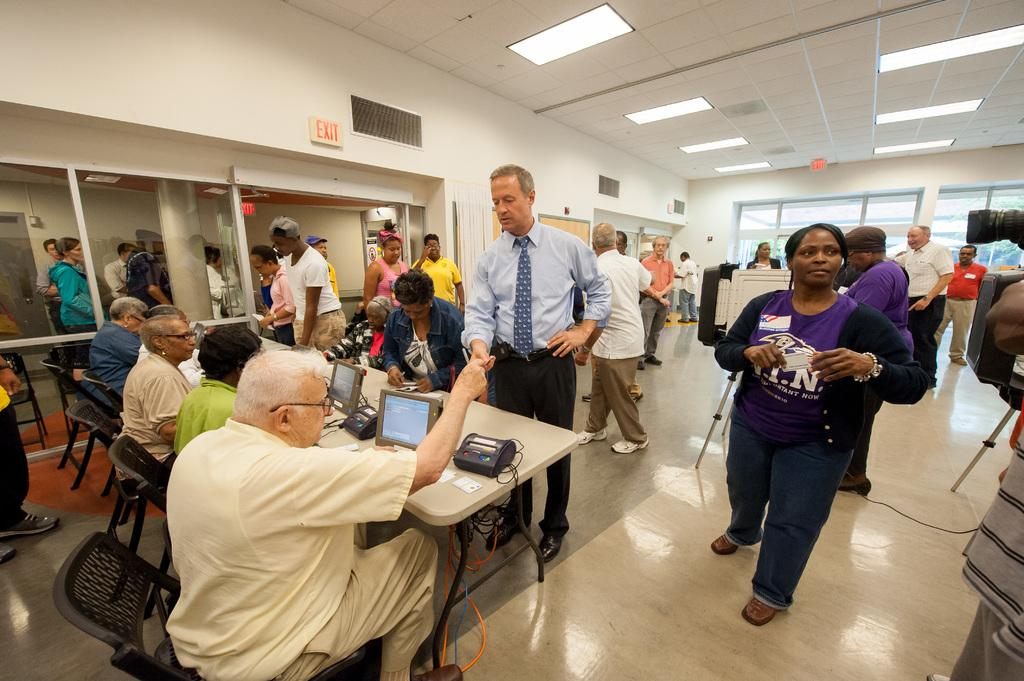<image>
Describe the image concisely. People are in a room with a red exit sign by the ceiling. 